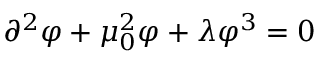<formula> <loc_0><loc_0><loc_500><loc_500>\partial ^ { 2 } \varphi + \mu _ { 0 } ^ { 2 } \varphi + \lambda \varphi ^ { 3 } = 0</formula> 